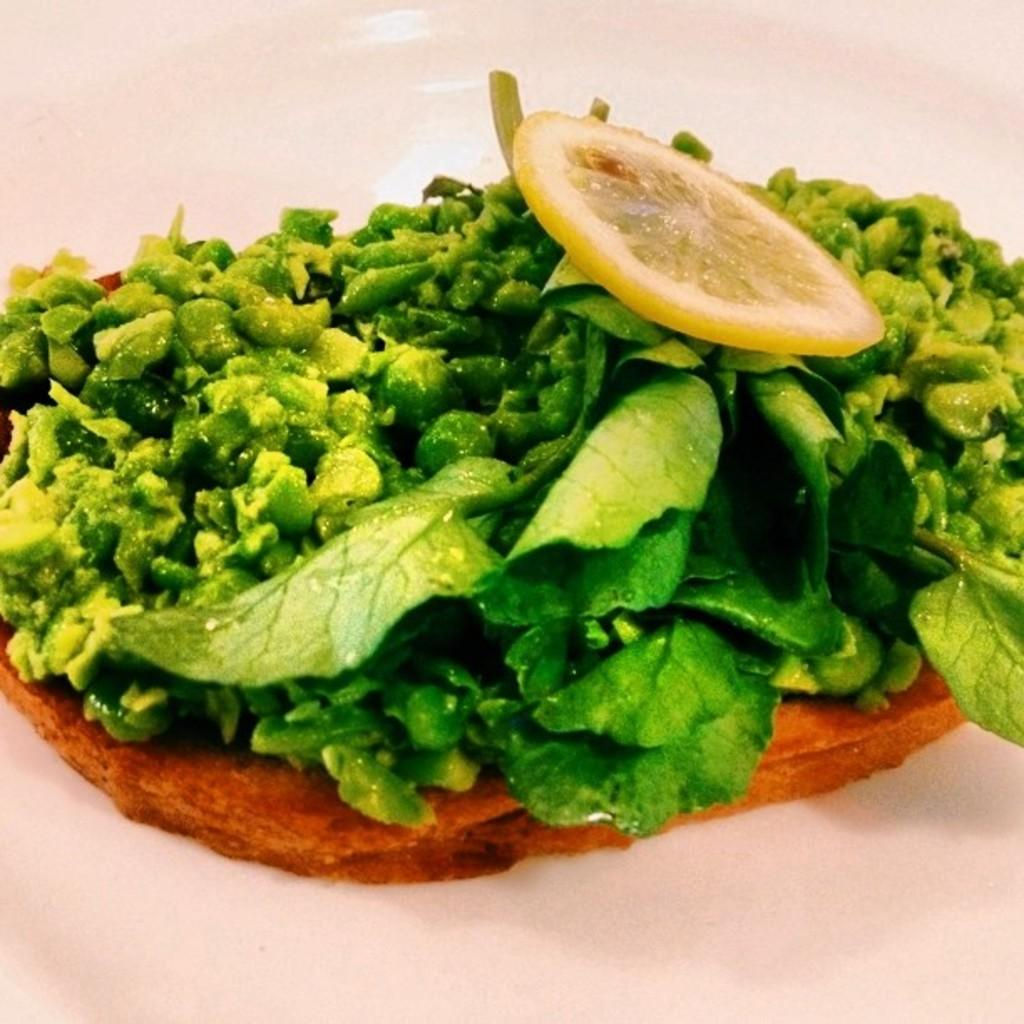What is the main subject of the image? The main subject of the image is a close-up of a food item. What is the background of the image? The food item is placed on a white surface. How many berries can be seen on the arm in the image? There are no berries or arms present in the image; it is a close-up of a food item placed on a white surface. 